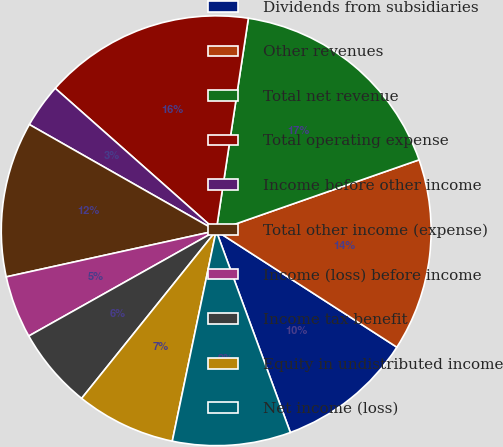Convert chart. <chart><loc_0><loc_0><loc_500><loc_500><pie_chart><fcel>Dividends from subsidiaries<fcel>Other revenues<fcel>Total net revenue<fcel>Total operating expense<fcel>Income before other income<fcel>Total other income (expense)<fcel>Income (loss) before income<fcel>Income tax benefit<fcel>Equity in undistributed income<fcel>Net income (loss)<nl><fcel>10.28%<fcel>14.46%<fcel>17.25%<fcel>15.86%<fcel>3.3%<fcel>11.67%<fcel>4.7%<fcel>6.09%<fcel>7.49%<fcel>8.88%<nl></chart> 